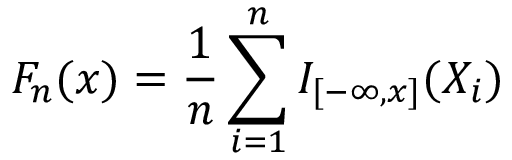<formula> <loc_0><loc_0><loc_500><loc_500>F _ { n } ( x ) = { \frac { 1 } { n } } \sum _ { i = 1 } ^ { n } I _ { [ - \infty , x ] } ( X _ { i } )</formula> 